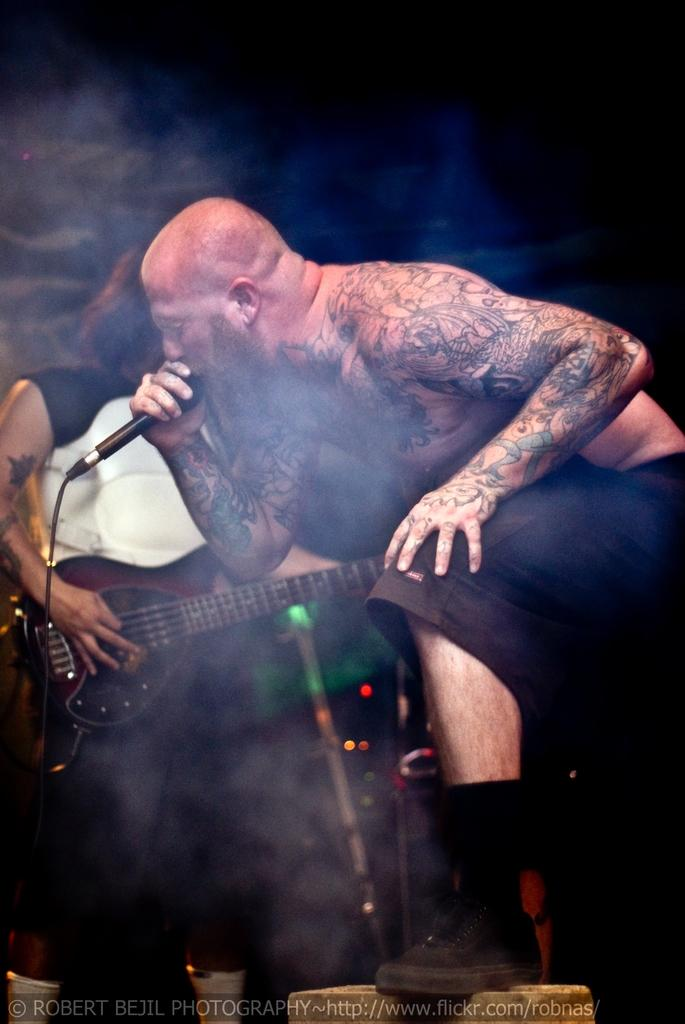How many people are in the image? There are two persons in the image. What are the two persons doing? One person is playing a musical instrument, and the other person is singing a song. Can you describe the actions of the two persons? One person is playing a musical instrument, while the other person is singing a song. What can be seen in the background of the image? There are lightning in the background of the image. Can you tell me how many donkeys are present in the image? There are no donkeys present in the image. What type of plane can be seen flying in the background of the image? There is no plane visible in the image; it features two people and lightning in the background. 